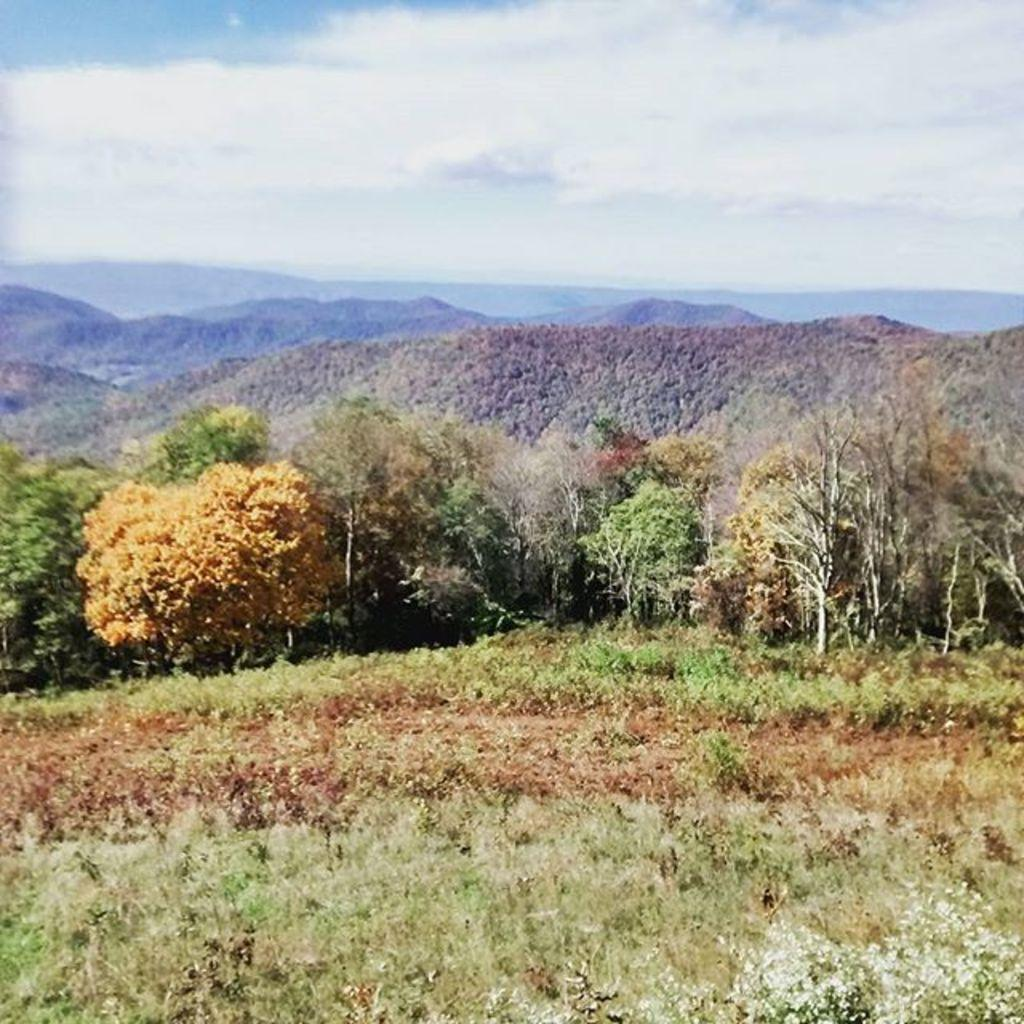What is visible in the center of the image? The sky is visible in the center of the image. What can be seen in the sky? Clouds are present in the image. What type of natural features are visible in the image? There are hills and trees visible in the image. What other types of vegetation are present in the image? Plants are present in the image. Are there any other objects visible in the image? Yes, there are a few other objects in the image. What type of chalk is being used to draw on the growth of the plant in the image? There is no chalk or plant growth present in the image. 